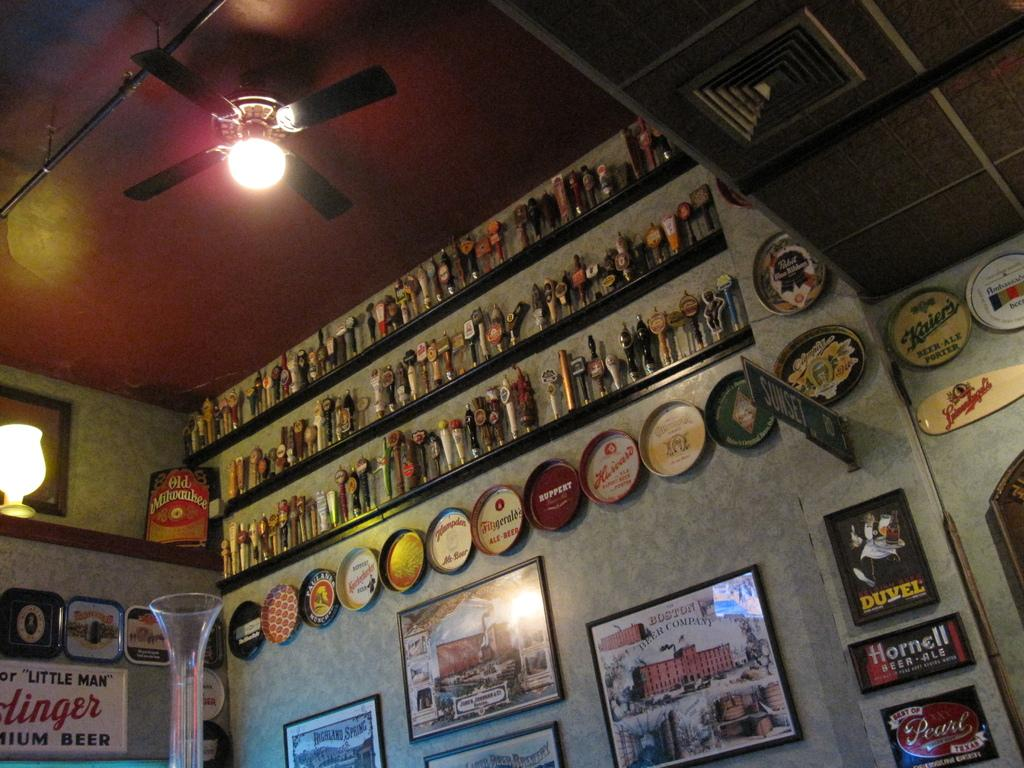What type of objects can be seen in the image? There are frames, plates, and objects on a rack in the image. What is attached to the wall in the image? Broad, possibly a type of cloth or fabric, is attached to the wall in the image. What type of illumination is present in the image? Lights are visible in the image. What part of the room can be seen in the image? The ceiling is visible in the image. Is there a volcano erupting in the middle of the image? No, there is no volcano or any indication of an eruption in the image. What type of field can be seen in the background of the image? There is no field visible in the image; it primarily features frames, plates, and objects on a rack. 